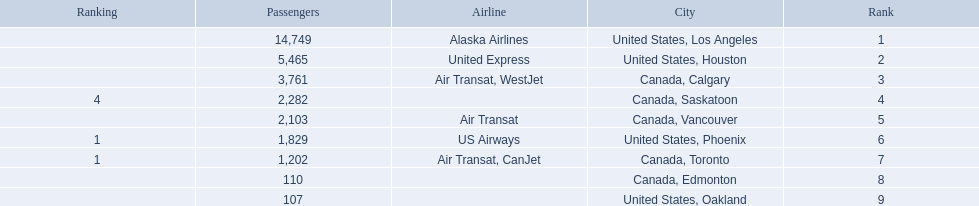What were all the passenger totals? 14,749, 5,465, 3,761, 2,282, 2,103, 1,829, 1,202, 110, 107. Which of these were to los angeles? 14,749. What other destination combined with this is closest to 19,000? Canada, Calgary. 